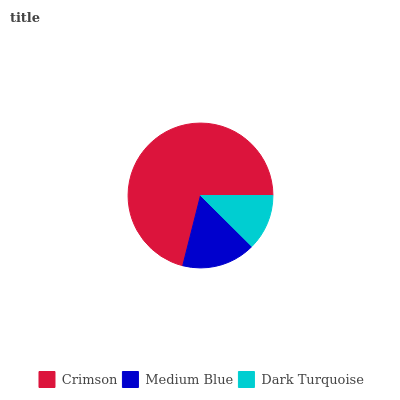Is Dark Turquoise the minimum?
Answer yes or no. Yes. Is Crimson the maximum?
Answer yes or no. Yes. Is Medium Blue the minimum?
Answer yes or no. No. Is Medium Blue the maximum?
Answer yes or no. No. Is Crimson greater than Medium Blue?
Answer yes or no. Yes. Is Medium Blue less than Crimson?
Answer yes or no. Yes. Is Medium Blue greater than Crimson?
Answer yes or no. No. Is Crimson less than Medium Blue?
Answer yes or no. No. Is Medium Blue the high median?
Answer yes or no. Yes. Is Medium Blue the low median?
Answer yes or no. Yes. Is Dark Turquoise the high median?
Answer yes or no. No. Is Crimson the low median?
Answer yes or no. No. 